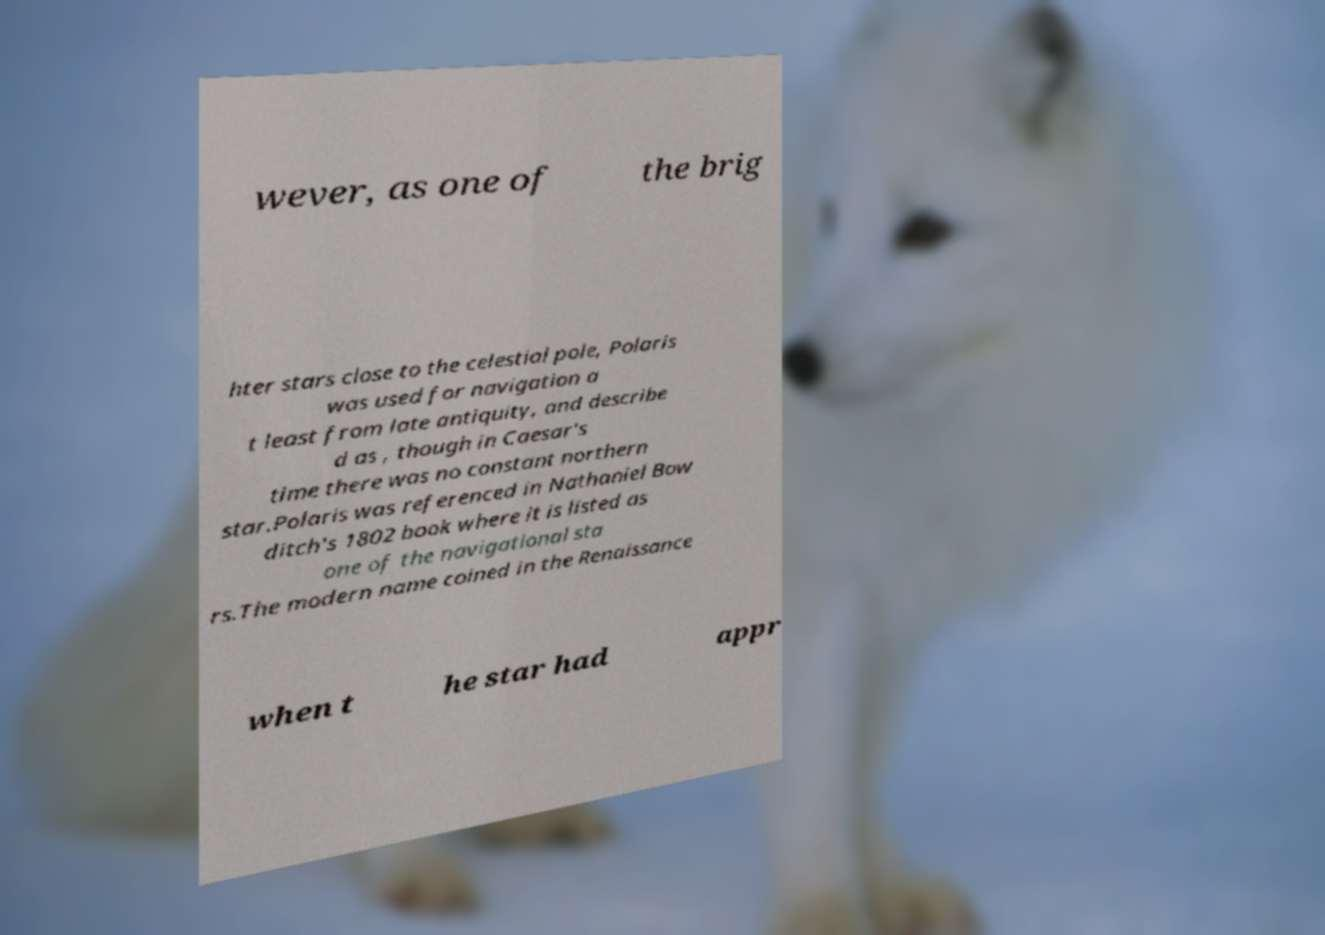Please identify and transcribe the text found in this image. wever, as one of the brig hter stars close to the celestial pole, Polaris was used for navigation a t least from late antiquity, and describe d as , though in Caesar's time there was no constant northern star.Polaris was referenced in Nathaniel Bow ditch's 1802 book where it is listed as one of the navigational sta rs.The modern name coined in the Renaissance when t he star had appr 